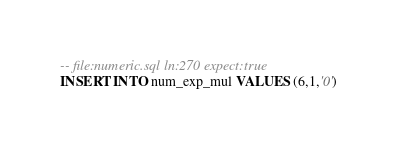Convert code to text. <code><loc_0><loc_0><loc_500><loc_500><_SQL_>-- file:numeric.sql ln:270 expect:true
INSERT INTO num_exp_mul VALUES (6,1,'0')
</code> 